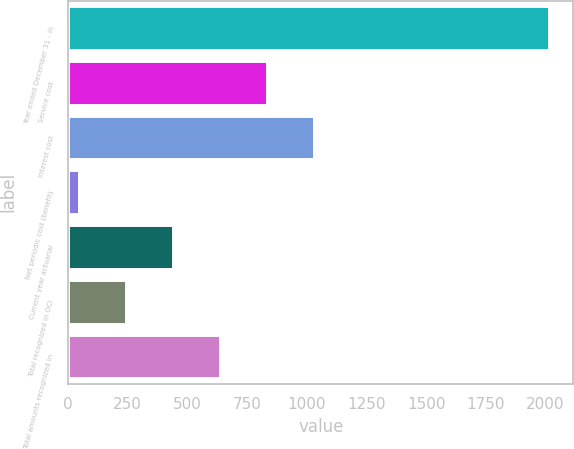<chart> <loc_0><loc_0><loc_500><loc_500><bar_chart><fcel>Year ended December 31 - in<fcel>Service cost<fcel>Interest cost<fcel>Net periodic cost (benefit)<fcel>Current year actuarial<fcel>Total recognized in OCI<fcel>Total amounts recognized in<nl><fcel>2016<fcel>833.4<fcel>1030.5<fcel>45<fcel>439.2<fcel>242.1<fcel>636.3<nl></chart> 